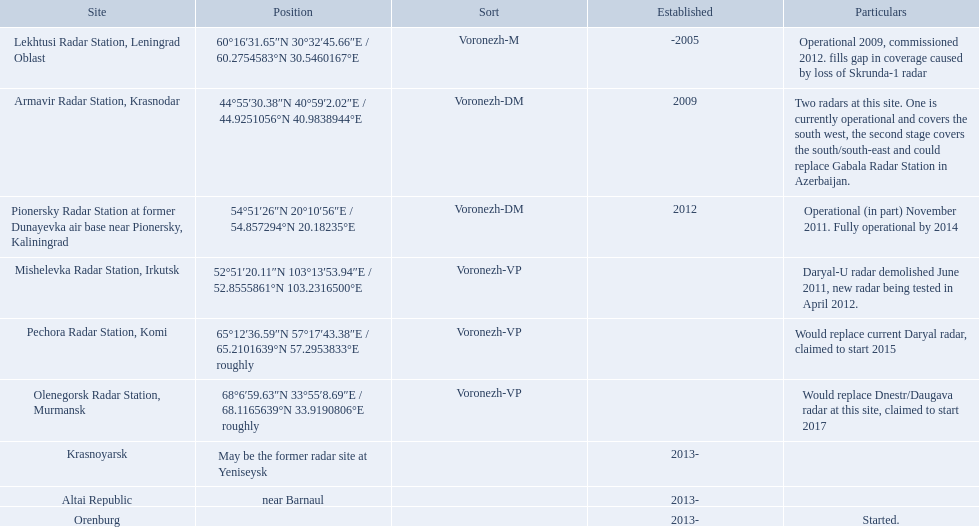Which voronezh radar has already started? Orenburg. Which radar would replace dnestr/daugava? Olenegorsk Radar Station, Murmansk. Which radar started in 2015? Pechora Radar Station, Komi. Which column has the coordinates starting with 60 deg? 60°16′31.65″N 30°32′45.66″E﻿ / ﻿60.2754583°N 30.5460167°E. What is the location in the same row as that column? Lekhtusi Radar Station, Leningrad Oblast. 